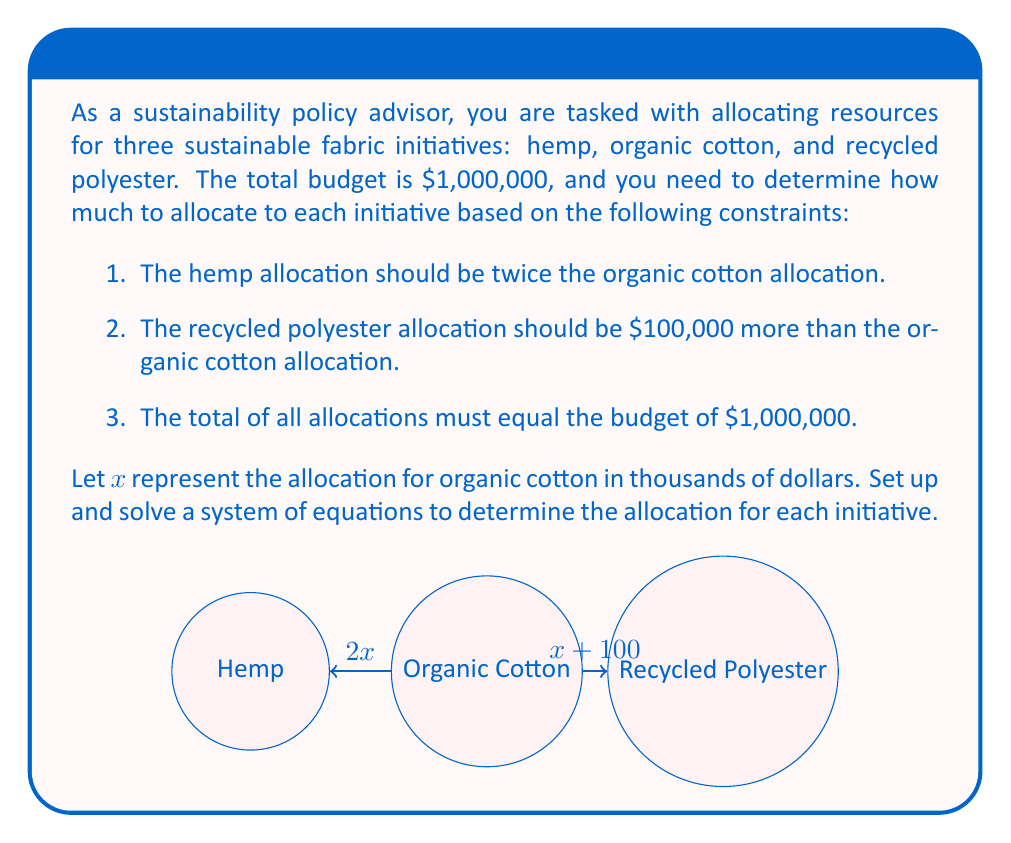Help me with this question. Let's solve this problem step by step:

1. Define variables:
   $x$ = organic cotton allocation (in thousands of dollars)
   $2x$ = hemp allocation (in thousands of dollars)
   $x + 100$ = recycled polyester allocation (in thousands of dollars)

2. Set up the equation based on the total budget constraint:
   $$x + 2x + (x + 100) = 1000$$

3. Simplify the equation:
   $$4x + 100 = 1000$$

4. Subtract 100 from both sides:
   $$4x = 900$$

5. Divide both sides by 4:
   $$x = 225$$

6. Now that we know $x$, we can calculate the other allocations:
   Organic cotton: $x = 225$ thousand dollars = $225,000
   Hemp: $2x = 2(225) = 450$ thousand dollars = $450,000
   Recycled polyester: $x + 100 = 225 + 100 = 325$ thousand dollars = $325,000

7. Verify that the total equals the budget:
   $$225,000 + 450,000 + 325,000 = 1,000,000$$

Therefore, the allocations are:
- Organic cotton: $225,000
- Hemp: $450,000
- Recycled polyester: $325,000
Answer: Organic cotton: $225,000; Hemp: $450,000; Recycled polyester: $325,000 